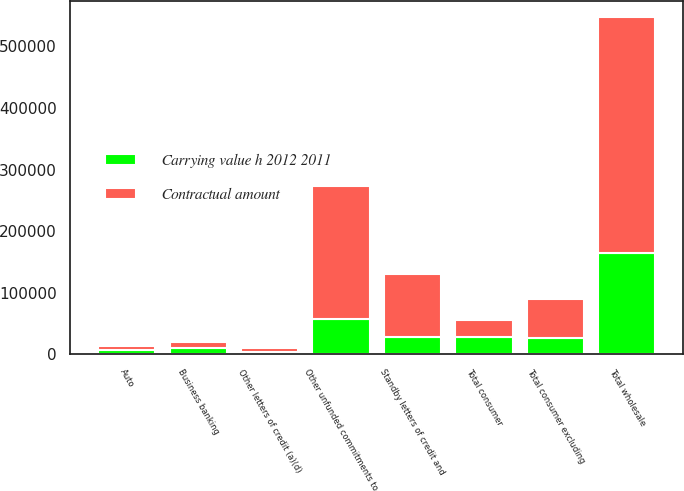Convert chart to OTSL. <chart><loc_0><loc_0><loc_500><loc_500><stacked_bar_chart><ecel><fcel>Auto<fcel>Business banking<fcel>Total consumer excluding<fcel>Total consumer<fcel>Other unfunded commitments to<fcel>Standby letters of credit and<fcel>Other letters of credit (a)(d)<fcel>Total wholesale<nl><fcel>Carrying value h 2012 2011<fcel>6916<fcel>10160<fcel>27089<fcel>27865<fcel>57443<fcel>28641<fcel>4276<fcel>164327<nl><fcel>Contractual amount<fcel>6694<fcel>10299<fcel>62307<fcel>27865<fcel>215251<fcel>101899<fcel>5386<fcel>382739<nl></chart> 